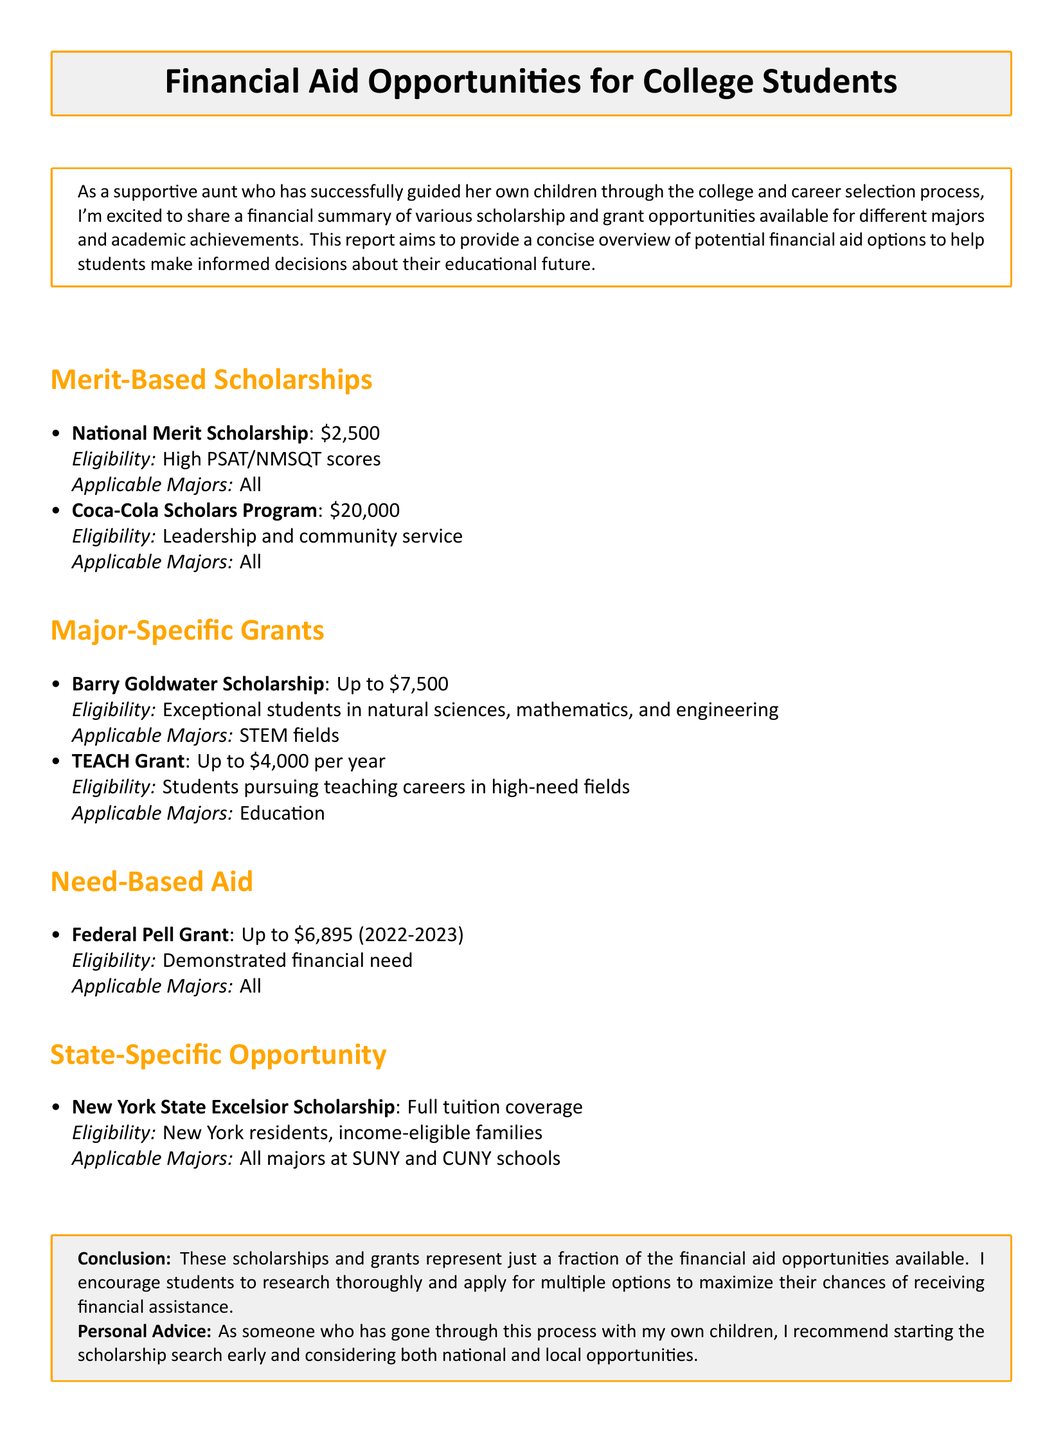What is the amount of the Federal Pell Grant? The Federal Pell Grant provides financial aid of up to $6,895 for the 2022-2023 year.
Answer: Up to $6,895 (2022-2023) What is required to be eligible for the New York State Excelsior Scholarship? The eligibility for the New York State Excelsior Scholarship is based on being a New York resident from an income-eligible family.
Answer: New York residents, income-eligible families What is the amount of the Coca-Cola Scholars Program? The Coca-Cola Scholars Program offers a scholarship of $20,000.
Answer: $20,000 Which scholarship is available for all majors? The National Merit Scholarship is applicable to all majors.
Answer: National Merit Scholarship How much funding does the TEACH Grant provide per year? The TEACH Grant can provide funding of up to $4,000 per year.
Answer: Up to $4,000 per year What fields must a student be exceptional in to qualify for the Barry Goldwater Scholarship? Students must be exceptional in the natural sciences, mathematics, and engineering to qualify for this scholarship.
Answer: STEM fields What is the purpose of the report? The report aims to provide an overview of potential financial aid options for students.
Answer: To help students make informed decisions about their educational future Which major does the TEACH Grant specifically target? The TEACH Grant targets students pursuing careers in education.
Answer: Education What is the conclusion's recommendation regarding the scholarship search? The conclusion advises that students should start the scholarship search early and consider various opportunities.
Answer: Start early and consider both national and local opportunities 